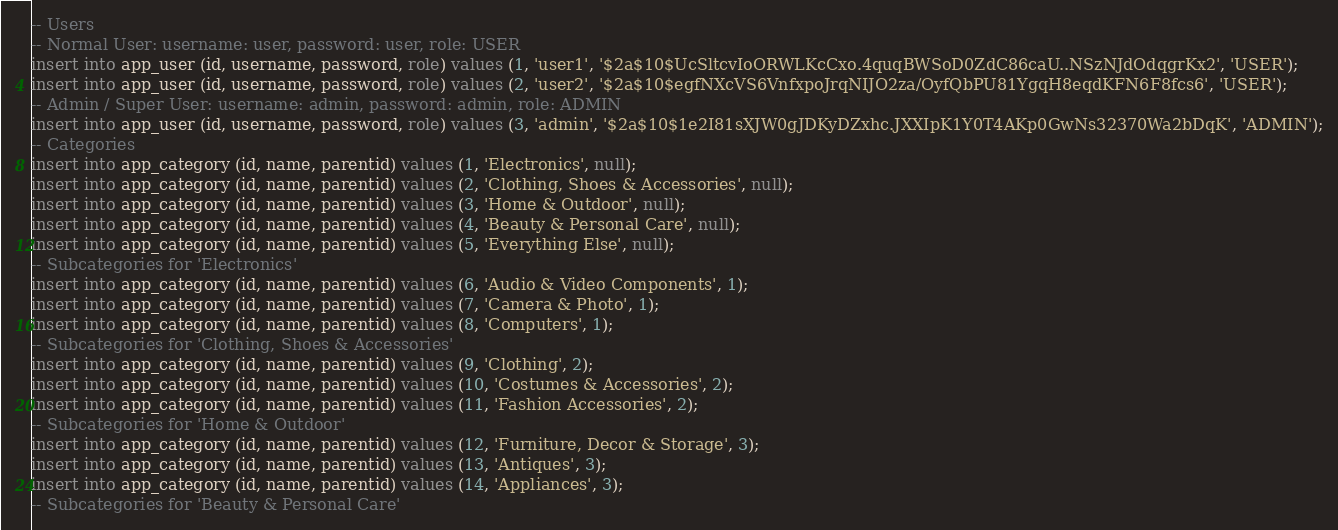Convert code to text. <code><loc_0><loc_0><loc_500><loc_500><_SQL_>-- Users
-- Normal User: username: user, password: user, role: USER
insert into app_user (id, username, password, role) values (1, 'user1', '$2a$10$UcSltcvIoORWLKcCxo.4quqBWSoD0ZdC86caU..NSzNJdOdqgrKx2', 'USER');
insert into app_user (id, username, password, role) values (2, 'user2', '$2a$10$egfNXcVS6VnfxpoJrqNIJO2za/OyfQbPU81YgqH8eqdKFN6F8fcs6', 'USER');
-- Admin / Super User: username: admin, password: admin, role: ADMIN
insert into app_user (id, username, password, role) values (3, 'admin', '$2a$10$1e2I81sXJW0gJDKyDZxhc.JXXIpK1Y0T4AKp0GwNs32370Wa2bDqK', 'ADMIN');
-- Categories
insert into app_category (id, name, parentid) values (1, 'Electronics', null);
insert into app_category (id, name, parentid) values (2, 'Clothing, Shoes & Accessories', null);
insert into app_category (id, name, parentid) values (3, 'Home & Outdoor', null);
insert into app_category (id, name, parentid) values (4, 'Beauty & Personal Care', null);
insert into app_category (id, name, parentid) values (5, 'Everything Else', null);
-- Subcategories for 'Electronics'
insert into app_category (id, name, parentid) values (6, 'Audio & Video Components', 1);
insert into app_category (id, name, parentid) values (7, 'Camera & Photo', 1);
insert into app_category (id, name, parentid) values (8, 'Computers', 1);
-- Subcategories for 'Clothing, Shoes & Accessories'
insert into app_category (id, name, parentid) values (9, 'Clothing', 2);
insert into app_category (id, name, parentid) values (10, 'Costumes & Accessories', 2);
insert into app_category (id, name, parentid) values (11, 'Fashion Accessories', 2);
-- Subcategories for 'Home & Outdoor'
insert into app_category (id, name, parentid) values (12, 'Furniture, Decor & Storage', 3);
insert into app_category (id, name, parentid) values (13, 'Antiques', 3);
insert into app_category (id, name, parentid) values (14, 'Appliances', 3);
-- Subcategories for 'Beauty & Personal Care'</code> 